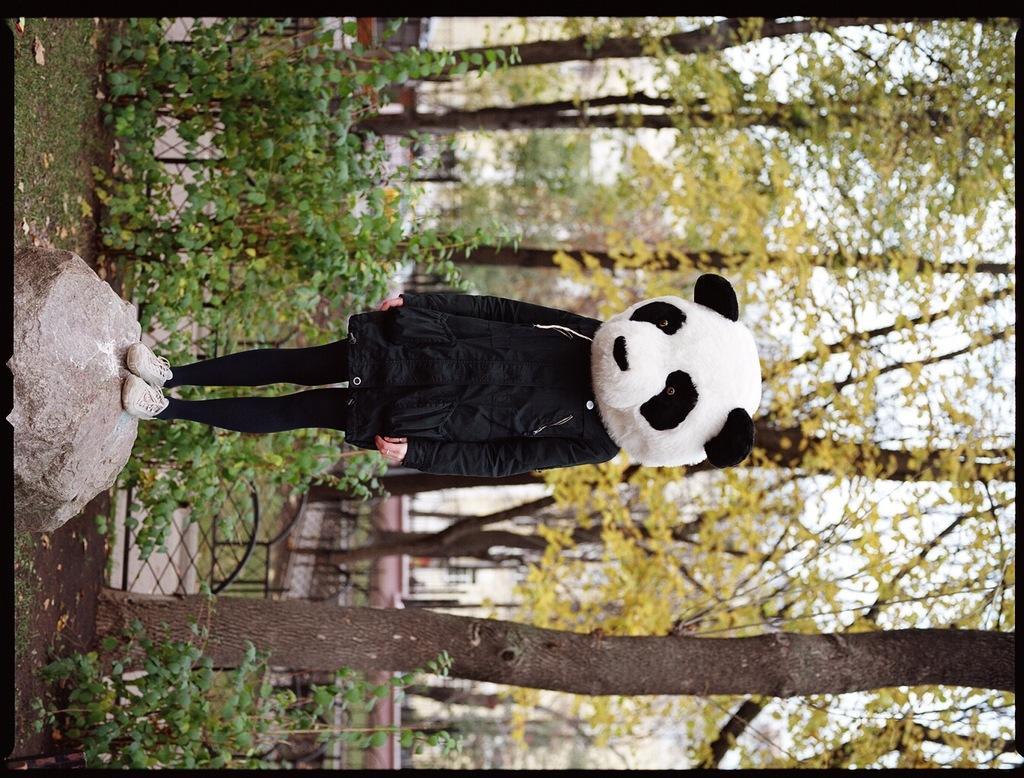How would you summarize this image in a sentence or two? In this image we can see a person is standing on the rock, and wearing the panda mask, there are the trees. 